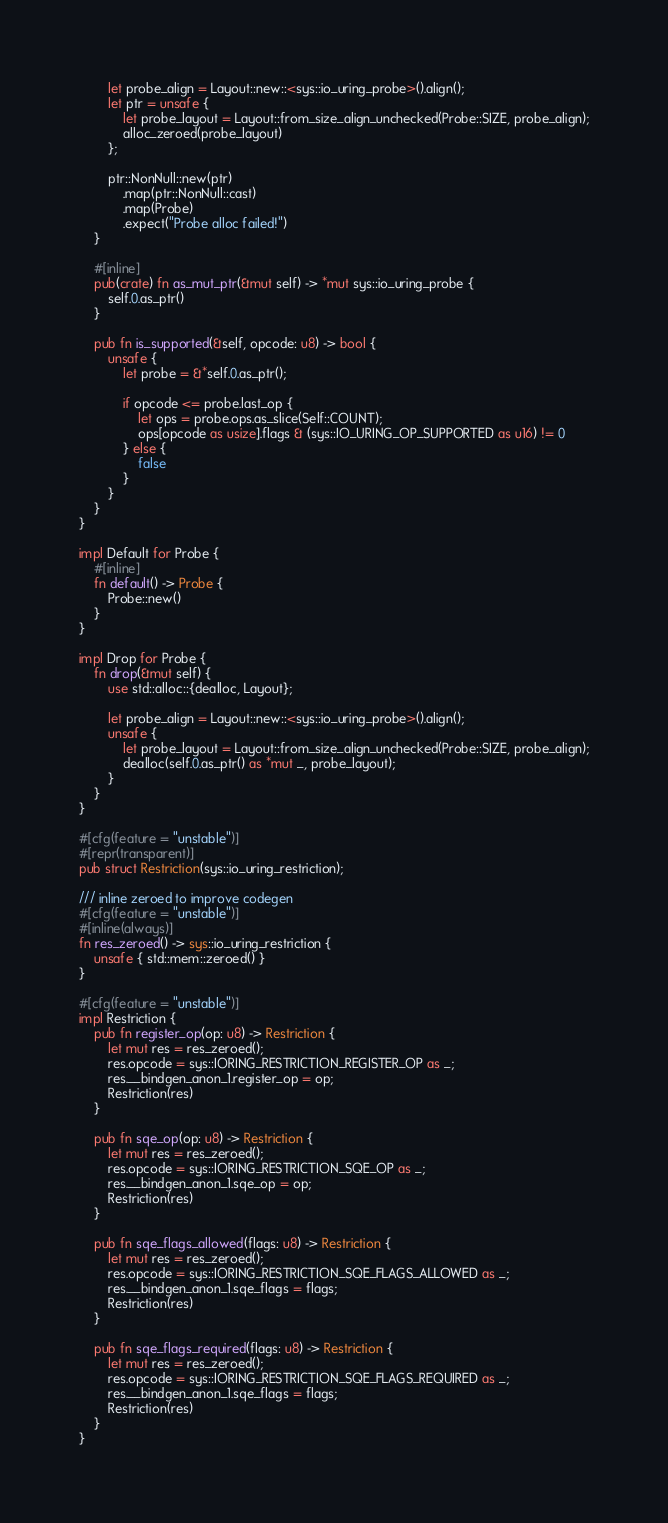<code> <loc_0><loc_0><loc_500><loc_500><_Rust_>
        let probe_align = Layout::new::<sys::io_uring_probe>().align();
        let ptr = unsafe {
            let probe_layout = Layout::from_size_align_unchecked(Probe::SIZE, probe_align);
            alloc_zeroed(probe_layout)
        };

        ptr::NonNull::new(ptr)
            .map(ptr::NonNull::cast)
            .map(Probe)
            .expect("Probe alloc failed!")
    }

    #[inline]
    pub(crate) fn as_mut_ptr(&mut self) -> *mut sys::io_uring_probe {
        self.0.as_ptr()
    }

    pub fn is_supported(&self, opcode: u8) -> bool {
        unsafe {
            let probe = &*self.0.as_ptr();

            if opcode <= probe.last_op {
                let ops = probe.ops.as_slice(Self::COUNT);
                ops[opcode as usize].flags & (sys::IO_URING_OP_SUPPORTED as u16) != 0
            } else {
                false
            }
        }
    }
}

impl Default for Probe {
    #[inline]
    fn default() -> Probe {
        Probe::new()
    }
}

impl Drop for Probe {
    fn drop(&mut self) {
        use std::alloc::{dealloc, Layout};

        let probe_align = Layout::new::<sys::io_uring_probe>().align();
        unsafe {
            let probe_layout = Layout::from_size_align_unchecked(Probe::SIZE, probe_align);
            dealloc(self.0.as_ptr() as *mut _, probe_layout);
        }
    }
}

#[cfg(feature = "unstable")]
#[repr(transparent)]
pub struct Restriction(sys::io_uring_restriction);

/// inline zeroed to improve codegen
#[cfg(feature = "unstable")]
#[inline(always)]
fn res_zeroed() -> sys::io_uring_restriction {
    unsafe { std::mem::zeroed() }
}

#[cfg(feature = "unstable")]
impl Restriction {
    pub fn register_op(op: u8) -> Restriction {
        let mut res = res_zeroed();
        res.opcode = sys::IORING_RESTRICTION_REGISTER_OP as _;
        res.__bindgen_anon_1.register_op = op;
        Restriction(res)
    }

    pub fn sqe_op(op: u8) -> Restriction {
        let mut res = res_zeroed();
        res.opcode = sys::IORING_RESTRICTION_SQE_OP as _;
        res.__bindgen_anon_1.sqe_op = op;
        Restriction(res)
    }

    pub fn sqe_flags_allowed(flags: u8) -> Restriction {
        let mut res = res_zeroed();
        res.opcode = sys::IORING_RESTRICTION_SQE_FLAGS_ALLOWED as _;
        res.__bindgen_anon_1.sqe_flags = flags;
        Restriction(res)
    }

    pub fn sqe_flags_required(flags: u8) -> Restriction {
        let mut res = res_zeroed();
        res.opcode = sys::IORING_RESTRICTION_SQE_FLAGS_REQUIRED as _;
        res.__bindgen_anon_1.sqe_flags = flags;
        Restriction(res)
    }
}
</code> 